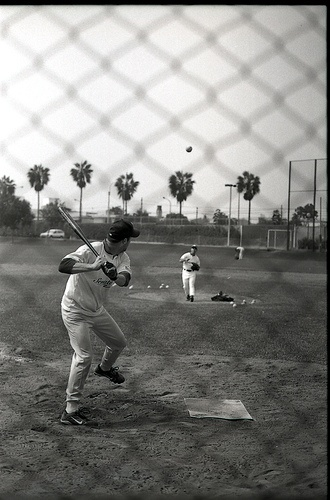Describe the objects in this image and their specific colors. I can see sports ball in black, gray, darkgray, and lightgray tones, people in black, gray, darkgray, and lightgray tones, people in black, darkgray, lightgray, and gray tones, baseball bat in black, gray, and darkgray tones, and car in black, gray, darkgray, and lightgray tones in this image. 